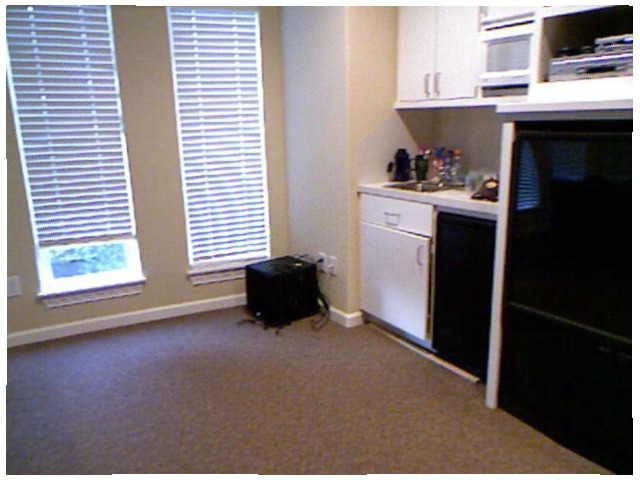<image>
Is the box on the floor? Yes. Looking at the image, I can see the box is positioned on top of the floor, with the floor providing support. Where is the drawer in relation to the book? Is it next to the book? No. The drawer is not positioned next to the book. They are located in different areas of the scene. 